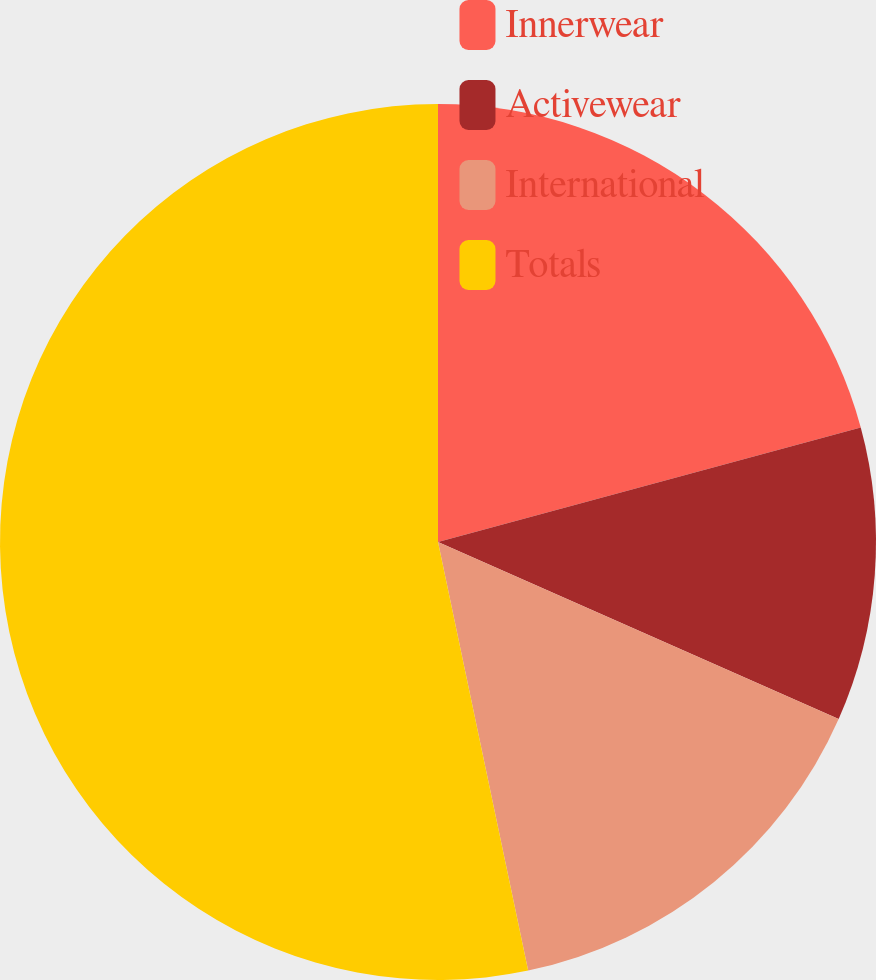<chart> <loc_0><loc_0><loc_500><loc_500><pie_chart><fcel>Innerwear<fcel>Activewear<fcel>International<fcel>Totals<nl><fcel>20.79%<fcel>10.83%<fcel>15.08%<fcel>53.3%<nl></chart> 